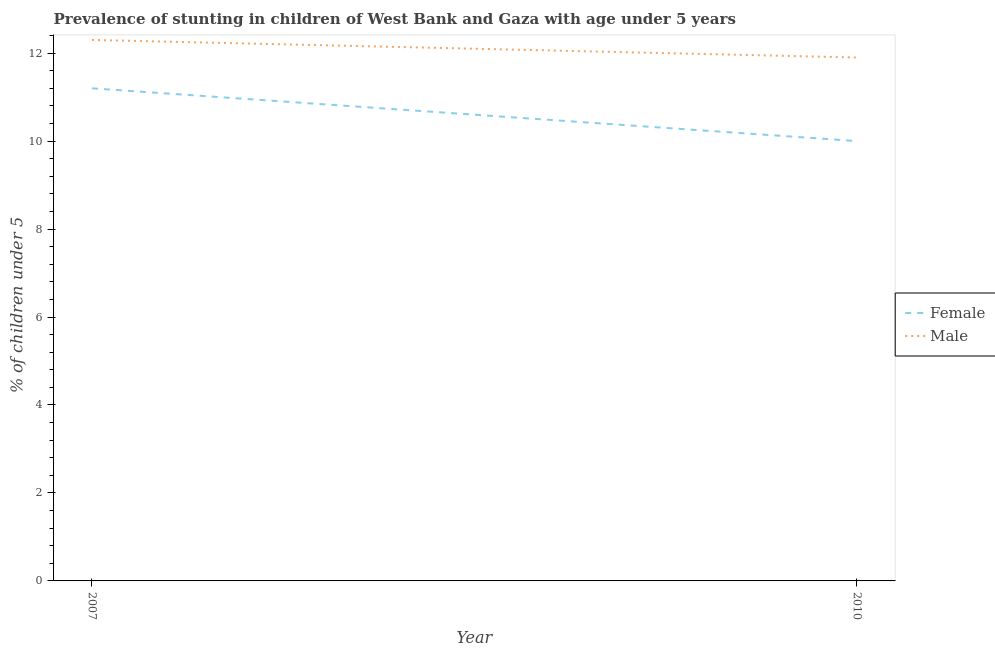Does the line corresponding to percentage of stunted male children intersect with the line corresponding to percentage of stunted female children?
Offer a terse response. No. Is the number of lines equal to the number of legend labels?
Give a very brief answer. Yes. What is the percentage of stunted male children in 2010?
Give a very brief answer. 11.9. Across all years, what is the maximum percentage of stunted female children?
Your answer should be very brief. 11.2. Across all years, what is the minimum percentage of stunted male children?
Offer a terse response. 11.9. What is the total percentage of stunted female children in the graph?
Your answer should be compact. 21.2. What is the difference between the percentage of stunted female children in 2007 and that in 2010?
Offer a terse response. 1.2. What is the difference between the percentage of stunted male children in 2007 and the percentage of stunted female children in 2010?
Give a very brief answer. 2.3. What is the average percentage of stunted male children per year?
Offer a terse response. 12.1. In the year 2007, what is the difference between the percentage of stunted female children and percentage of stunted male children?
Keep it short and to the point. -1.1. What is the ratio of the percentage of stunted male children in 2007 to that in 2010?
Provide a short and direct response. 1.03. Is the percentage of stunted female children in 2007 less than that in 2010?
Give a very brief answer. No. Is the percentage of stunted male children strictly less than the percentage of stunted female children over the years?
Make the answer very short. No. How many lines are there?
Offer a very short reply. 2. How many years are there in the graph?
Your response must be concise. 2. What is the difference between two consecutive major ticks on the Y-axis?
Provide a succinct answer. 2. Are the values on the major ticks of Y-axis written in scientific E-notation?
Make the answer very short. No. Does the graph contain grids?
Your response must be concise. No. How many legend labels are there?
Offer a very short reply. 2. What is the title of the graph?
Your answer should be very brief. Prevalence of stunting in children of West Bank and Gaza with age under 5 years. What is the label or title of the Y-axis?
Your response must be concise.  % of children under 5. What is the  % of children under 5 in Female in 2007?
Provide a short and direct response. 11.2. What is the  % of children under 5 in Male in 2007?
Make the answer very short. 12.3. What is the  % of children under 5 of Male in 2010?
Ensure brevity in your answer.  11.9. Across all years, what is the maximum  % of children under 5 of Female?
Give a very brief answer. 11.2. Across all years, what is the maximum  % of children under 5 in Male?
Provide a short and direct response. 12.3. Across all years, what is the minimum  % of children under 5 of Female?
Offer a terse response. 10. Across all years, what is the minimum  % of children under 5 of Male?
Your response must be concise. 11.9. What is the total  % of children under 5 in Female in the graph?
Provide a short and direct response. 21.2. What is the total  % of children under 5 in Male in the graph?
Give a very brief answer. 24.2. What is the difference between the  % of children under 5 of Female in 2007 and that in 2010?
Offer a very short reply. 1.2. What is the difference between the  % of children under 5 of Female in 2007 and the  % of children under 5 of Male in 2010?
Keep it short and to the point. -0.7. What is the average  % of children under 5 of Male per year?
Ensure brevity in your answer.  12.1. In the year 2010, what is the difference between the  % of children under 5 of Female and  % of children under 5 of Male?
Provide a succinct answer. -1.9. What is the ratio of the  % of children under 5 of Female in 2007 to that in 2010?
Make the answer very short. 1.12. What is the ratio of the  % of children under 5 in Male in 2007 to that in 2010?
Provide a succinct answer. 1.03. What is the difference between the highest and the second highest  % of children under 5 in Female?
Make the answer very short. 1.2. What is the difference between the highest and the second highest  % of children under 5 of Male?
Ensure brevity in your answer.  0.4. What is the difference between the highest and the lowest  % of children under 5 of Female?
Your answer should be compact. 1.2. What is the difference between the highest and the lowest  % of children under 5 in Male?
Offer a very short reply. 0.4. 